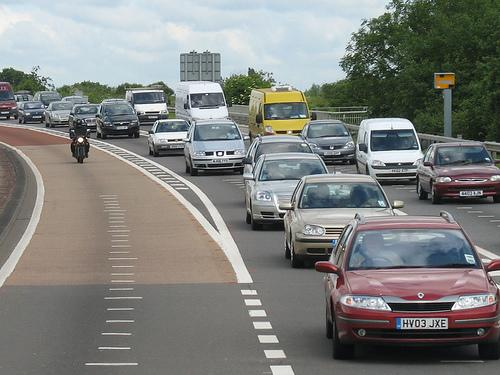What color are the lines painted in the middle of the road's lanes? White. Estimate the number of vehicles that are visible in the image. Around 12 vehicles are visible in the image. How many lanes are visible on the busy highway? There are two visible lanes. Enumerate the different types of vehicles on the road. Motorcycle, car, yellow van, white van, black van, and silver car. Describe the surroundings of the road. The surroundings of the road include green trees and bushes alongside the highway. From the given image, is there any mention of a bicycle in the image? No, there is no mention of a bicycle in the image. What is the main activity happening in this scene? Vehicles are traveling down a busy highway. What objects can be seen in the sky and what are their colors? Clouds can be seen in the sky, and they are white. What part of the motorcycle is illuminated? headlight Expresá en tus propias palabras qué está pasando en la carretera. Hay una carretera concurrida con varios vehículos incluyendo autos, camionetas y una motocicleta en movimiento. Hay árboles verdes al costado de la carretera, un arbusto verde cerca y un cielo nublado. Point out the vehicles moving on the highway. red car, yellow van, silver car, white car, white van, black van, silver car, burgundy car, motorcycle What can you say about the cars traveling on the highway? There are several cars of different colors and models traveling down the highway. Select the different types of vehicles on the road. cars, vans, and a motorcycle Is the headlight of the motorcycle colored yellow? No, it's not mentioned in the image. Does the green bush have pink blossoms on it? The bush is only described as green, with no mention of any blossoms, especially not pink ones. Is the car driving on the left side of the road? There is a mention of a person driving on the right side of the car, which indicates that the car is most likely driving on the right side of the road. Describe the appearance of the clouds. The clouds are white. Based on the objects and their descriptions, what is a possible location? a busy highway with trees and clouds Identify any specific type of activity happening on the road. cars, vans, and a motorcycle traveling down the highway Is the windshield of the car cracked? The windshield is mentioned as an object in the image but there is no mention of it being cracked. Are there any palm trees along the side of the road? The trees mentioned beside the highway are described as green, but there is no mention of them being palm trees. What type of activity is the person on the motorcycle doing? riding the motorcycle What type of vehicle has a headlight on? the motorcycle Read the visible license plate on the car. HV03 JXE Rank the vehicles by their size: cars, vans, and a motorcycle. 1. vans, 2. cars, 3. motorcycle Combined with the image, create a story about a journey encountering a busy highway. While driving on a long journey, the traveler approached a busy highway filled with cars, vans, and a motorcycle. They marveled at the various colors and models of the vehicles and the picturesque scene of the green trees on the side of the road and the white clouds in the sky. What color is the bush next to the road? green Which object on the road is related to safety and visibility? headlight on the motorcycle Which object in the scene emits light? Answer:  In your own words, describe the scene with the vehicles and the environment. A busy highway with various vehicles including cars, vans, and a motorcycle driving along the road. There are green trees on the side of the road, a green bush nearby, and a cloudy sky overhead. Is the license plate on the car colored purple? The license plate is described as hv03 jxe, which has no mention of being purple. Describe the lines in the middle of the lane. white lines, some are dashed What side of the car is the person driving on? Choose the correct answer. A. left side B. right side C. front side D. back side B. right side What emotion does the driver of the car have?  Unable to determine emotion from the given information. 